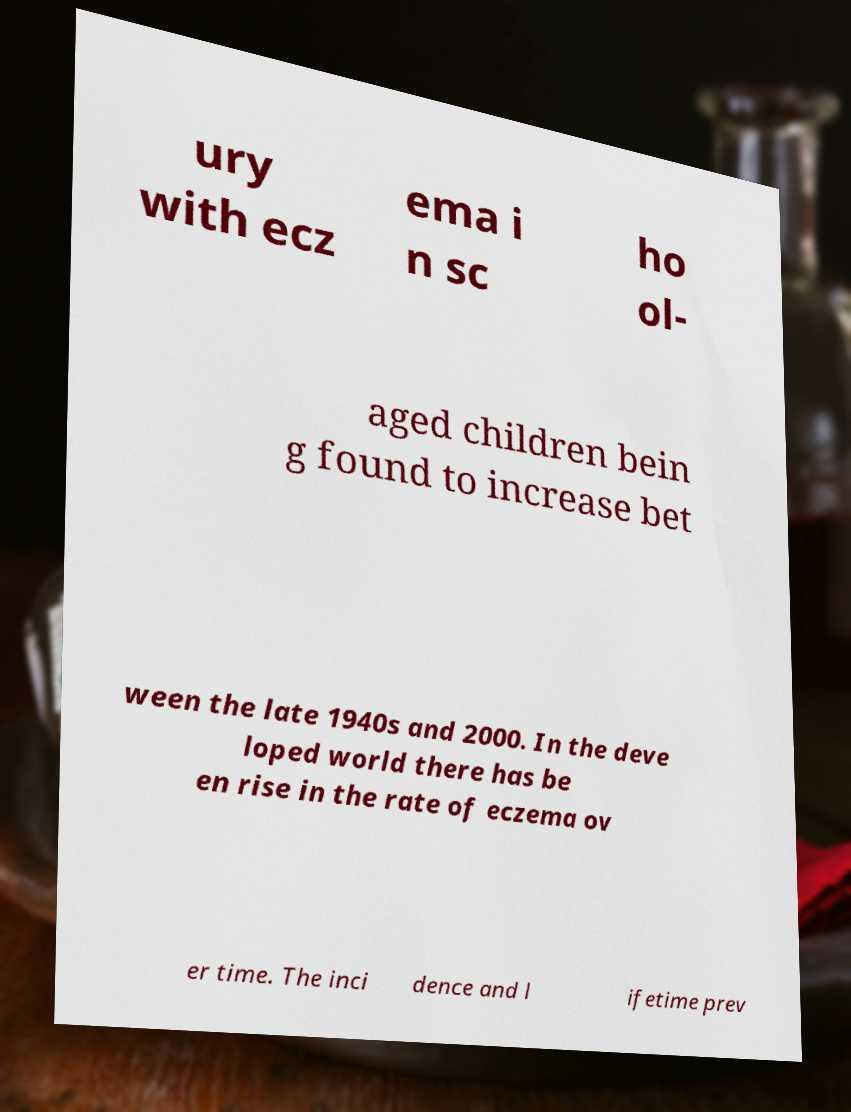For documentation purposes, I need the text within this image transcribed. Could you provide that? ury with ecz ema i n sc ho ol- aged children bein g found to increase bet ween the late 1940s and 2000. In the deve loped world there has be en rise in the rate of eczema ov er time. The inci dence and l ifetime prev 